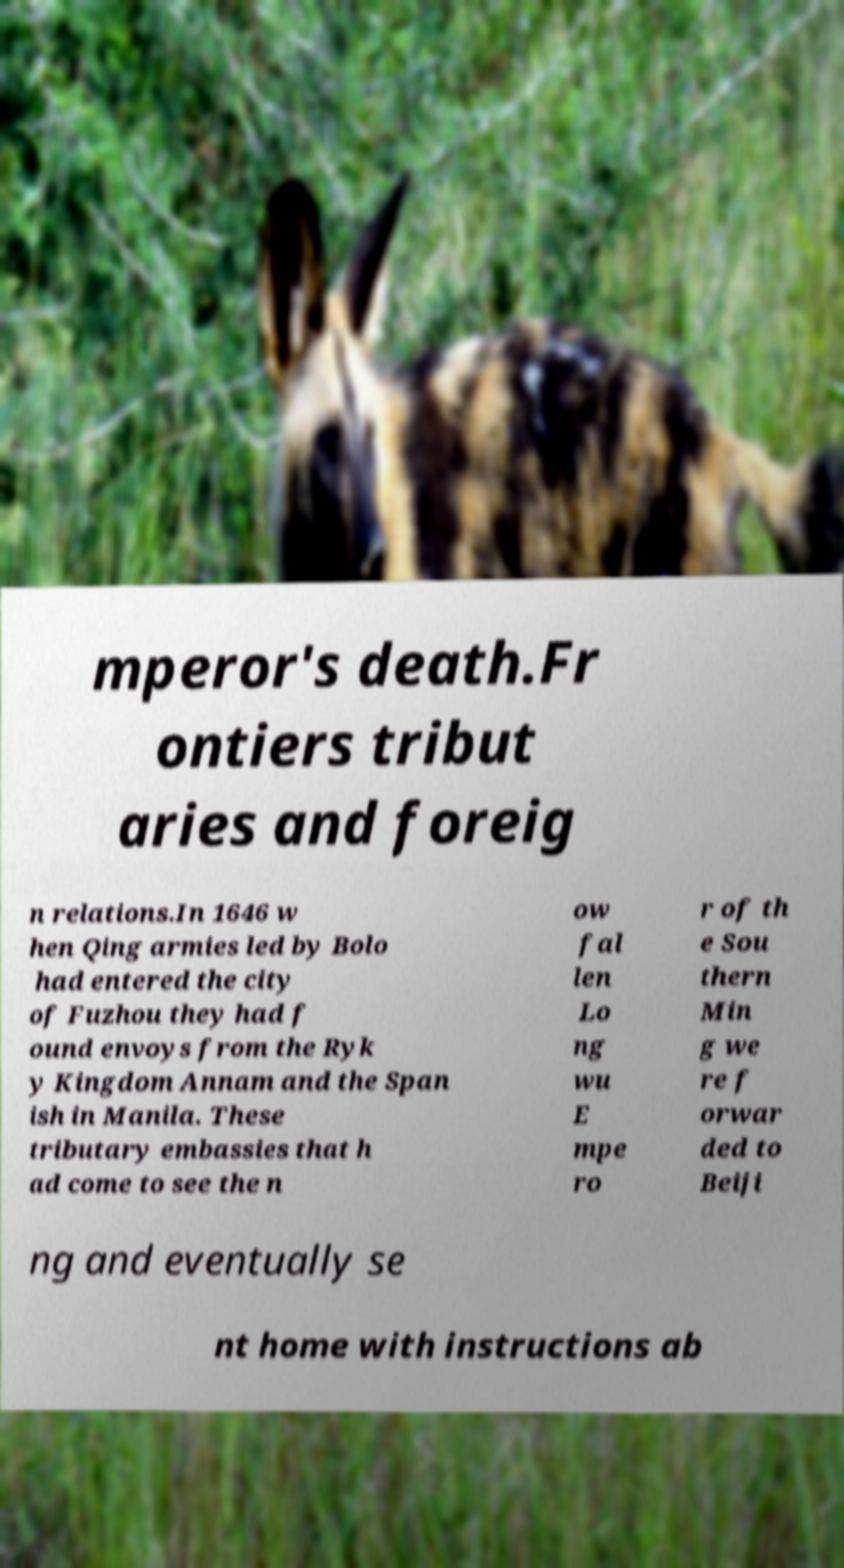Could you assist in decoding the text presented in this image and type it out clearly? mperor's death.Fr ontiers tribut aries and foreig n relations.In 1646 w hen Qing armies led by Bolo had entered the city of Fuzhou they had f ound envoys from the Ryk y Kingdom Annam and the Span ish in Manila. These tributary embassies that h ad come to see the n ow fal len Lo ng wu E mpe ro r of th e Sou thern Min g we re f orwar ded to Beiji ng and eventually se nt home with instructions ab 